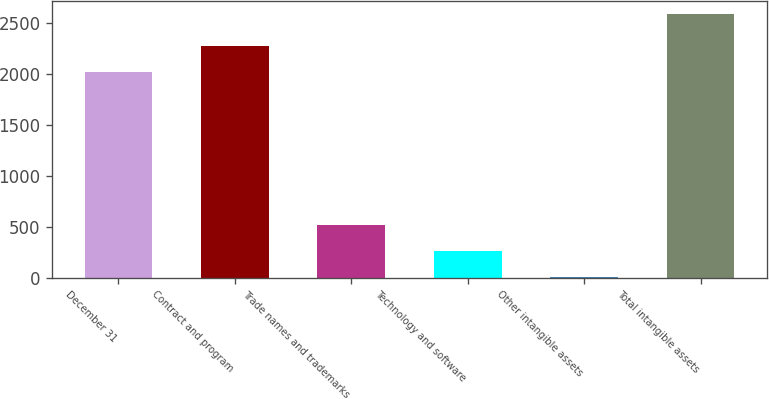<chart> <loc_0><loc_0><loc_500><loc_500><bar_chart><fcel>December 31<fcel>Contract and program<fcel>Trade names and trademarks<fcel>Technology and software<fcel>Other intangible assets<fcel>Total intangible assets<nl><fcel>2018<fcel>2276.1<fcel>520.2<fcel>262.1<fcel>4<fcel>2585<nl></chart> 